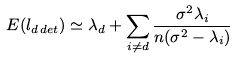<formula> <loc_0><loc_0><loc_500><loc_500>E ( l _ { d \, d e t } ) \simeq \lambda _ { d } + \sum _ { i \neq d } \frac { \sigma ^ { 2 } \lambda _ { i } } { n ( \sigma ^ { 2 } - \lambda _ { i } ) }</formula> 